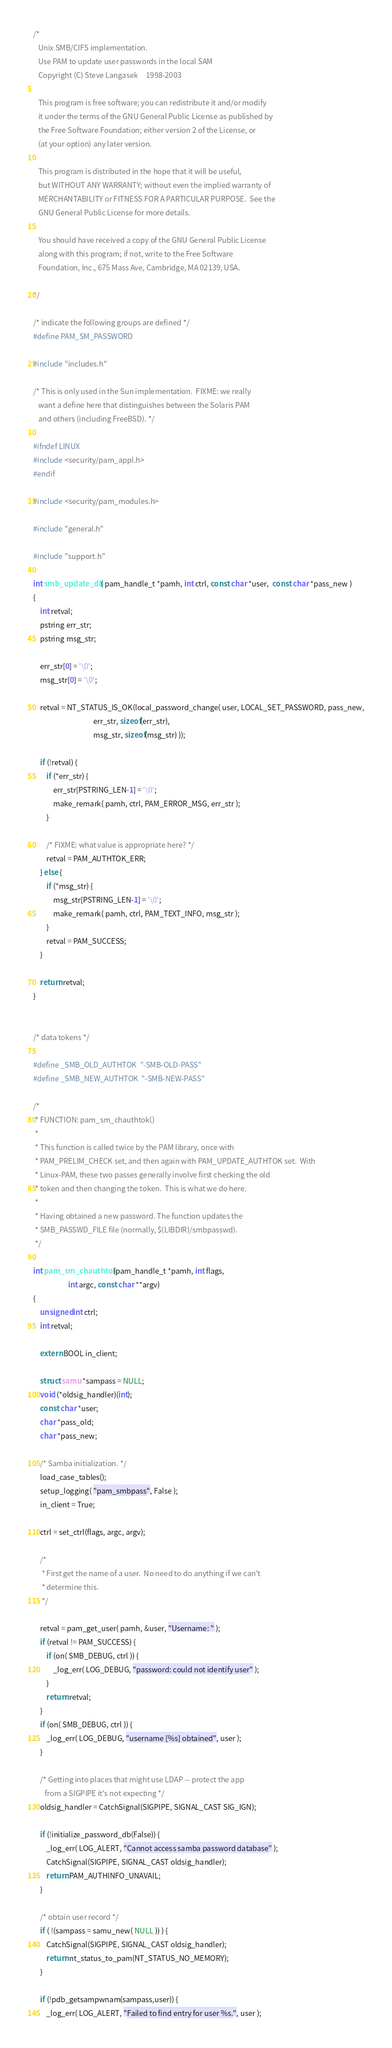<code> <loc_0><loc_0><loc_500><loc_500><_C_>/*
   Unix SMB/CIFS implementation.
   Use PAM to update user passwords in the local SAM
   Copyright (C) Steve Langasek		1998-2003
   
   This program is free software; you can redistribute it and/or modify
   it under the terms of the GNU General Public License as published by
   the Free Software Foundation; either version 2 of the License, or
   (at your option) any later version.
   
   This program is distributed in the hope that it will be useful,
   but WITHOUT ANY WARRANTY; without even the implied warranty of
   MERCHANTABILITY or FITNESS FOR A PARTICULAR PURPOSE.  See the
   GNU General Public License for more details.
   
   You should have received a copy of the GNU General Public License
   along with this program; if not, write to the Free Software
   Foundation, Inc., 675 Mass Ave, Cambridge, MA 02139, USA.

*/

/* indicate the following groups are defined */
#define PAM_SM_PASSWORD

#include "includes.h"

/* This is only used in the Sun implementation.  FIXME: we really
   want a define here that distinguishes between the Solaris PAM
   and others (including FreeBSD). */

#ifndef LINUX
#include <security/pam_appl.h>
#endif

#include <security/pam_modules.h>

#include "general.h" 

#include "support.h"

int smb_update_db( pam_handle_t *pamh, int ctrl, const char *user,  const char *pass_new )
{
	int retval;
	pstring err_str;
	pstring msg_str;

	err_str[0] = '\0';
	msg_str[0] = '\0';

	retval = NT_STATUS_IS_OK(local_password_change( user, LOCAL_SET_PASSWORD, pass_new,
	                                err_str, sizeof(err_str),
	                                msg_str, sizeof(msg_str) ));

	if (!retval) {
		if (*err_str) {
			err_str[PSTRING_LEN-1] = '\0';
			make_remark( pamh, ctrl, PAM_ERROR_MSG, err_str );
		}

		/* FIXME: what value is appropriate here? */
		retval = PAM_AUTHTOK_ERR;
	} else {
		if (*msg_str) {
			msg_str[PSTRING_LEN-1] = '\0';
			make_remark( pamh, ctrl, PAM_TEXT_INFO, msg_str );
		}
		retval = PAM_SUCCESS;
	}

	return retval;      
}


/* data tokens */

#define _SMB_OLD_AUTHTOK  "-SMB-OLD-PASS"
#define _SMB_NEW_AUTHTOK  "-SMB-NEW-PASS"

/*
 * FUNCTION: pam_sm_chauthtok()
 *
 * This function is called twice by the PAM library, once with
 * PAM_PRELIM_CHECK set, and then again with PAM_UPDATE_AUTHTOK set.  With
 * Linux-PAM, these two passes generally involve first checking the old
 * token and then changing the token.  This is what we do here.
 *
 * Having obtained a new password. The function updates the
 * SMB_PASSWD_FILE file (normally, $(LIBDIR)/smbpasswd).
 */

int pam_sm_chauthtok(pam_handle_t *pamh, int flags,
                     int argc, const char **argv)
{
    unsigned int ctrl;
    int retval;

    extern BOOL in_client;

    struct samu *sampass = NULL;
    void (*oldsig_handler)(int);
    const char *user;
    char *pass_old;
    char *pass_new;

    /* Samba initialization. */
    load_case_tables();
    setup_logging( "pam_smbpass", False );
    in_client = True;

    ctrl = set_ctrl(flags, argc, argv);

    /*
     * First get the name of a user.  No need to do anything if we can't
     * determine this.
     */

    retval = pam_get_user( pamh, &user, "Username: " );
    if (retval != PAM_SUCCESS) {
        if (on( SMB_DEBUG, ctrl )) {
            _log_err( LOG_DEBUG, "password: could not identify user" );
        }
        return retval;
    }
    if (on( SMB_DEBUG, ctrl )) {
        _log_err( LOG_DEBUG, "username [%s] obtained", user );
    }

    /* Getting into places that might use LDAP -- protect the app
       from a SIGPIPE it's not expecting */
    oldsig_handler = CatchSignal(SIGPIPE, SIGNAL_CAST SIG_IGN);

    if (!initialize_password_db(False)) {
        _log_err( LOG_ALERT, "Cannot access samba password database" );
        CatchSignal(SIGPIPE, SIGNAL_CAST oldsig_handler);
        return PAM_AUTHINFO_UNAVAIL;
    }

    /* obtain user record */
    if ( !(sampass = samu_new( NULL )) ) {
        CatchSignal(SIGPIPE, SIGNAL_CAST oldsig_handler);
        return nt_status_to_pam(NT_STATUS_NO_MEMORY);
    }

    if (!pdb_getsampwnam(sampass,user)) {
        _log_err( LOG_ALERT, "Failed to find entry for user %s.", user );</code> 